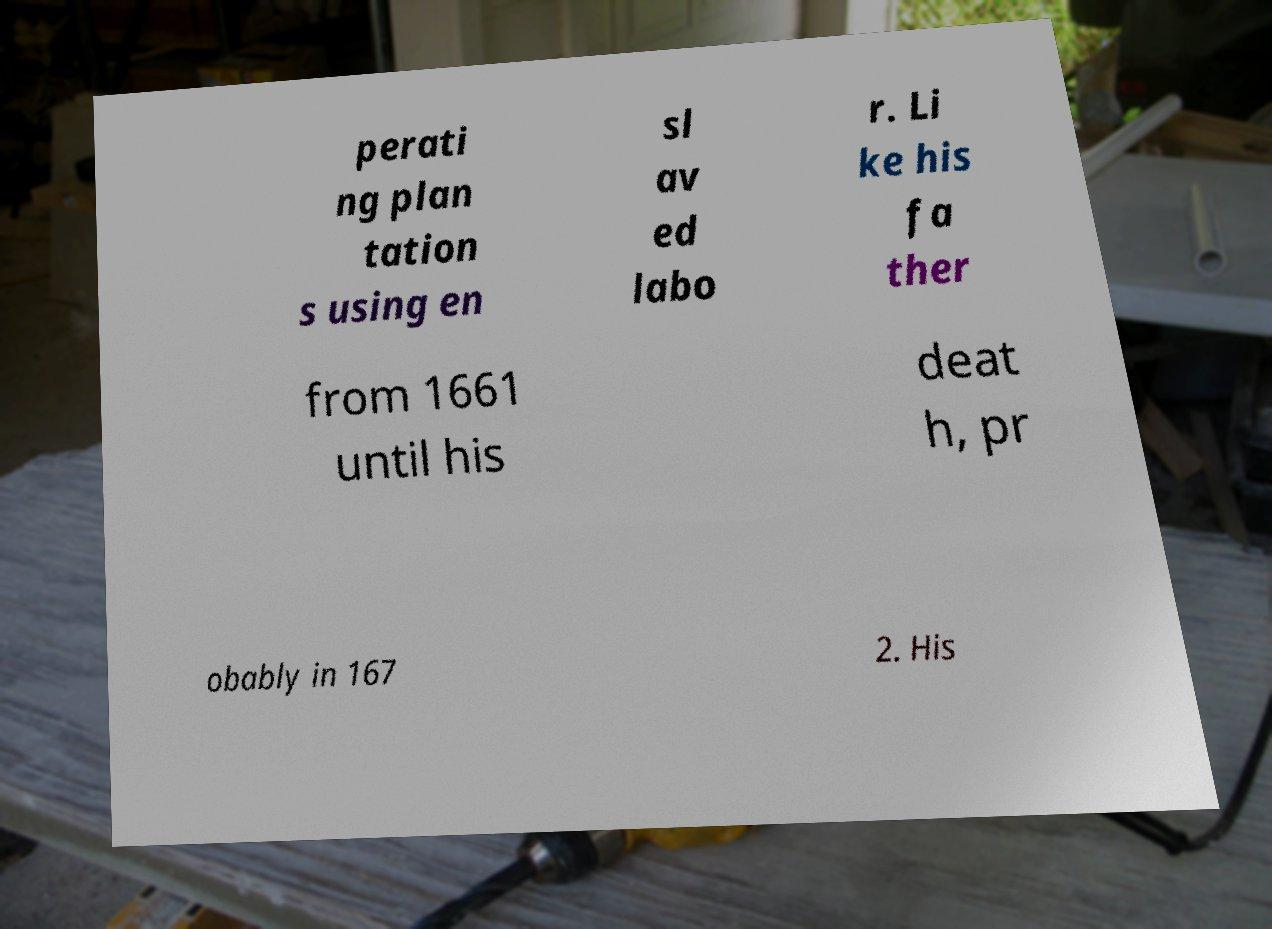I need the written content from this picture converted into text. Can you do that? perati ng plan tation s using en sl av ed labo r. Li ke his fa ther from 1661 until his deat h, pr obably in 167 2. His 